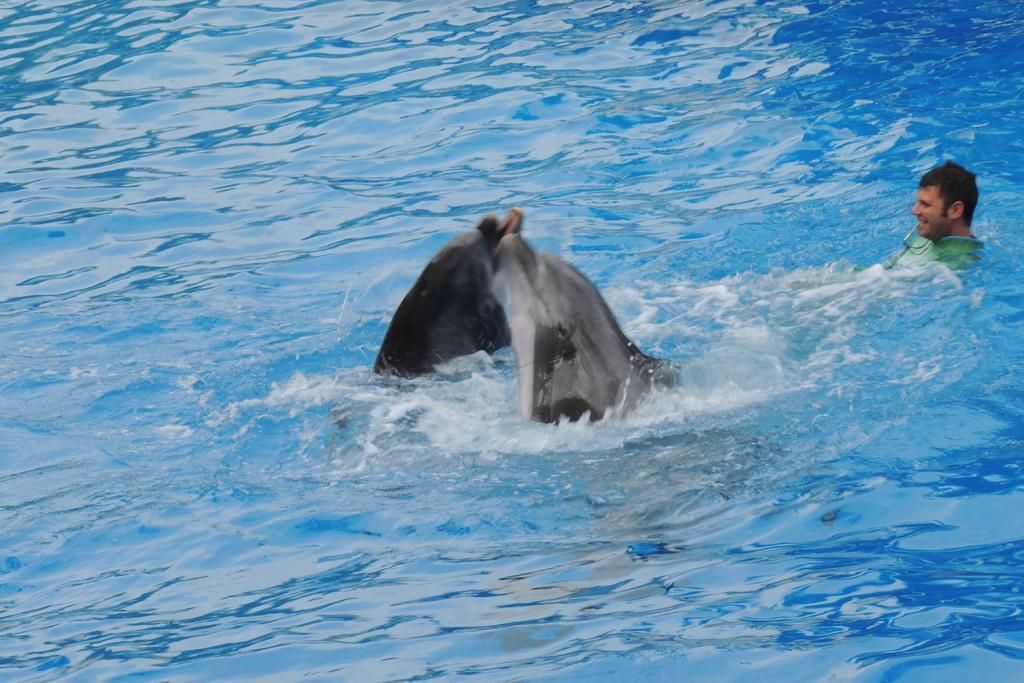In one or two sentences, can you explain what this image depicts? In this picture I can see a person in the water along with the ships. 